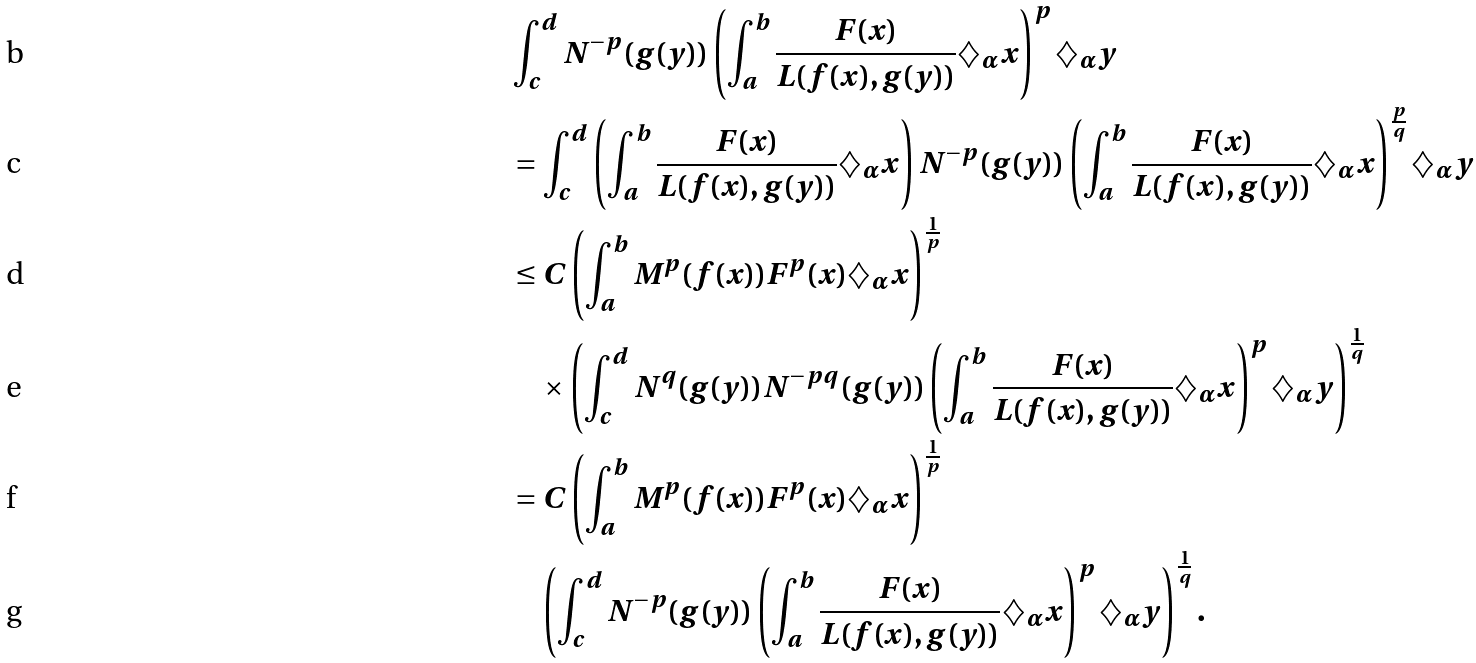<formula> <loc_0><loc_0><loc_500><loc_500>& \int _ { c } ^ { d } N ^ { - p } ( g ( y ) ) \left ( \int _ { a } ^ { b } \frac { F ( x ) } { L ( f ( x ) , g ( y ) ) } \diamondsuit _ { \alpha } x \right ) ^ { p } \diamondsuit _ { \alpha } y \\ & = \int _ { c } ^ { d } \left ( \int _ { a } ^ { b } \frac { F ( x ) } { L ( f ( x ) , g ( y ) ) } \diamondsuit _ { \alpha } x \right ) N ^ { - p } ( g ( y ) ) \left ( \int _ { a } ^ { b } \frac { F ( x ) } { L ( f ( x ) , g ( y ) ) } \diamondsuit _ { \alpha } x \right ) ^ { \frac { p } { q } } \diamondsuit _ { \alpha } y \\ & \leq C \left ( \int _ { a } ^ { b } M ^ { p } ( f ( x ) ) F ^ { p } ( x ) \diamondsuit _ { \alpha } x \right ) ^ { \frac { 1 } { p } } \\ & \quad \times \left ( \int _ { c } ^ { d } N ^ { q } ( g ( y ) ) N ^ { - p q } ( g ( y ) ) \left ( \int _ { a } ^ { b } \frac { F ( x ) } { L ( f ( x ) , g ( y ) ) } \diamondsuit _ { \alpha } x \right ) ^ { p } \diamondsuit _ { \alpha } y \right ) ^ { \frac { 1 } { q } } \\ & = C \left ( \int _ { a } ^ { b } M ^ { p } ( f ( x ) ) F ^ { p } ( x ) \diamondsuit _ { \alpha } x \right ) ^ { \frac { 1 } { p } } \\ & \quad \left ( \int _ { c } ^ { d } N ^ { - p } ( g ( y ) ) \left ( \int _ { a } ^ { b } \frac { F ( x ) } { L ( f ( x ) , g ( y ) ) } \diamondsuit _ { \alpha } x \right ) ^ { p } \diamondsuit _ { \alpha } y \right ) ^ { \frac { 1 } { q } } .</formula> 